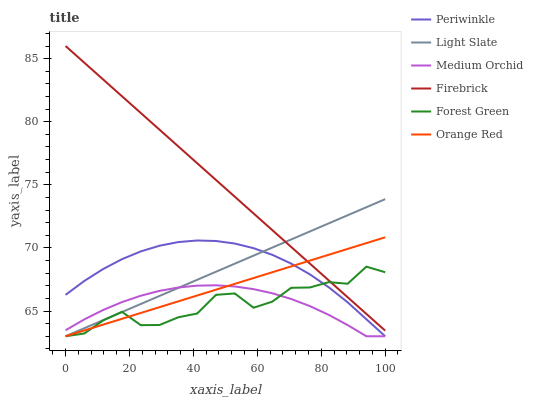Does Medium Orchid have the minimum area under the curve?
Answer yes or no. Yes. Does Firebrick have the maximum area under the curve?
Answer yes or no. Yes. Does Firebrick have the minimum area under the curve?
Answer yes or no. No. Does Medium Orchid have the maximum area under the curve?
Answer yes or no. No. Is Firebrick the smoothest?
Answer yes or no. Yes. Is Forest Green the roughest?
Answer yes or no. Yes. Is Medium Orchid the smoothest?
Answer yes or no. No. Is Medium Orchid the roughest?
Answer yes or no. No. Does Light Slate have the lowest value?
Answer yes or no. Yes. Does Firebrick have the lowest value?
Answer yes or no. No. Does Firebrick have the highest value?
Answer yes or no. Yes. Does Medium Orchid have the highest value?
Answer yes or no. No. Is Medium Orchid less than Firebrick?
Answer yes or no. Yes. Is Firebrick greater than Periwinkle?
Answer yes or no. Yes. Does Firebrick intersect Light Slate?
Answer yes or no. Yes. Is Firebrick less than Light Slate?
Answer yes or no. No. Is Firebrick greater than Light Slate?
Answer yes or no. No. Does Medium Orchid intersect Firebrick?
Answer yes or no. No. 